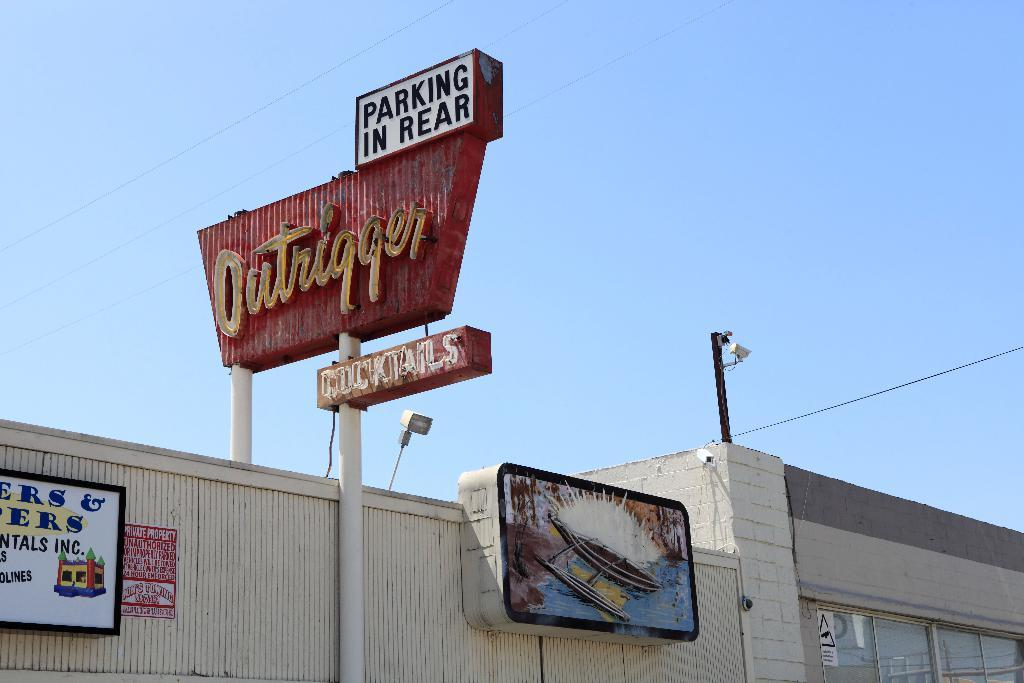What type of structures are located at the bottom of the image? There are buildings at the bottom of the image. What can be seen on the boards in the image? There are boards with text on them in the image. What are the poles used for in the image? The poles are likely used to support the wires in the image. What are the lights used for in the image? The lights may be used for illumination or signaling purposes. What is visible at the top of the image? The sky is visible at the top of the image. What type of pie is being served at the top of the image? There is no pie present in the image; it only features buildings, boards with text, poles, wires, lights, and the sky. Can you see a net being used for a sporting event in the image? There is no net or sporting event present in the image. 